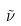<formula> <loc_0><loc_0><loc_500><loc_500>\tilde { \nu }</formula> 